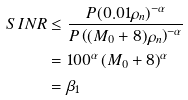<formula> <loc_0><loc_0><loc_500><loc_500>S I N R & \leq \frac { P ( 0 . 0 1 \rho _ { n } ) ^ { - \alpha } } { P \left ( ( M _ { 0 } + 8 ) \rho _ { n } \right ) ^ { - \alpha } } \\ & = 1 0 0 ^ { \alpha } \left ( { M _ { 0 } + 8 } \right ) ^ { \alpha } \\ & = \beta _ { 1 }</formula> 